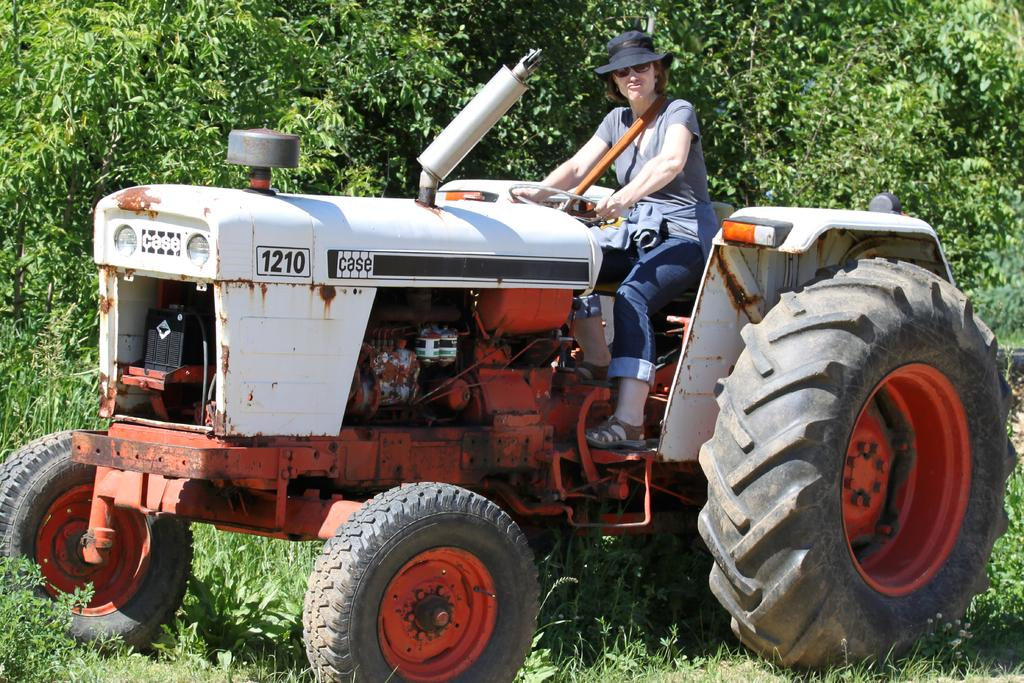What is the person in the image doing? There is a person sitting on a tractor in the image. What type of clothing is the person wearing on their upper body? The person is wearing a t-shirt. What type of clothing is the person wearing on their lower body? The person is wearing trousers. What type of headwear is the person wearing? The person is wearing a black color hat. What can be seen in the background of the image? There are trees in the image. Can you see a frog jumping on the tractor in the image? No, there is no frog present in the image. How many thumbs does the person have on their hands in the image? The image does not show the person's hands, so it is impossible to determine the number of thumbs they have. 